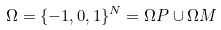Convert formula to latex. <formula><loc_0><loc_0><loc_500><loc_500>\Omega = \{ - 1 , 0 , 1 \} ^ { N } = \Omega P \cup \Omega M</formula> 